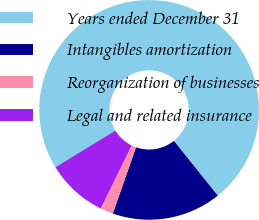Convert chart to OTSL. <chart><loc_0><loc_0><loc_500><loc_500><pie_chart><fcel>Years ended December 31<fcel>Intangibles amortization<fcel>Reorganization of businesses<fcel>Legal and related insurance<nl><fcel>73.0%<fcel>16.11%<fcel>1.89%<fcel>9.0%<nl></chart> 